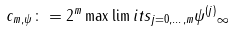<formula> <loc_0><loc_0><loc_500><loc_500>c _ { m , \psi } \colon = 2 ^ { m } \max \lim i t s _ { j = 0 , \dots , m } \| \psi ^ { ( j ) } \| _ { \infty }</formula> 